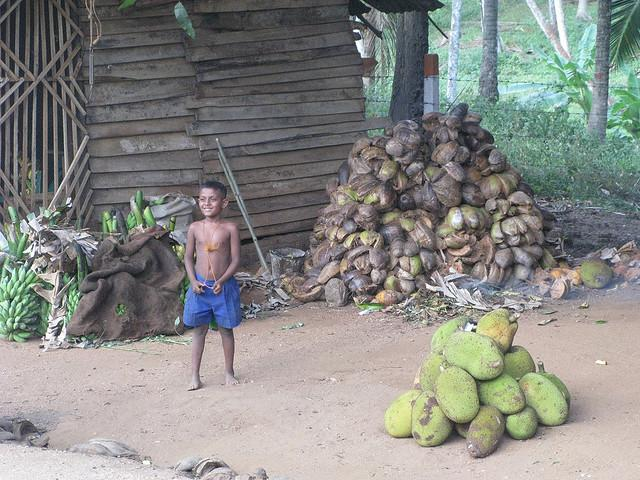What type of fruit are the green items on the boys right? Please explain your reasoning. bananas. They are in a half circle type shape and are green before they will turn ripe and yellow. 